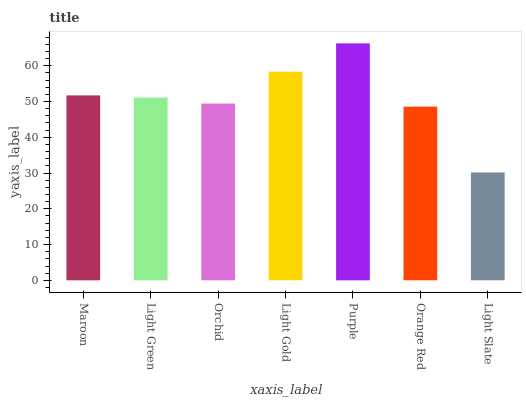Is Light Slate the minimum?
Answer yes or no. Yes. Is Purple the maximum?
Answer yes or no. Yes. Is Light Green the minimum?
Answer yes or no. No. Is Light Green the maximum?
Answer yes or no. No. Is Maroon greater than Light Green?
Answer yes or no. Yes. Is Light Green less than Maroon?
Answer yes or no. Yes. Is Light Green greater than Maroon?
Answer yes or no. No. Is Maroon less than Light Green?
Answer yes or no. No. Is Light Green the high median?
Answer yes or no. Yes. Is Light Green the low median?
Answer yes or no. Yes. Is Orange Red the high median?
Answer yes or no. No. Is Purple the low median?
Answer yes or no. No. 